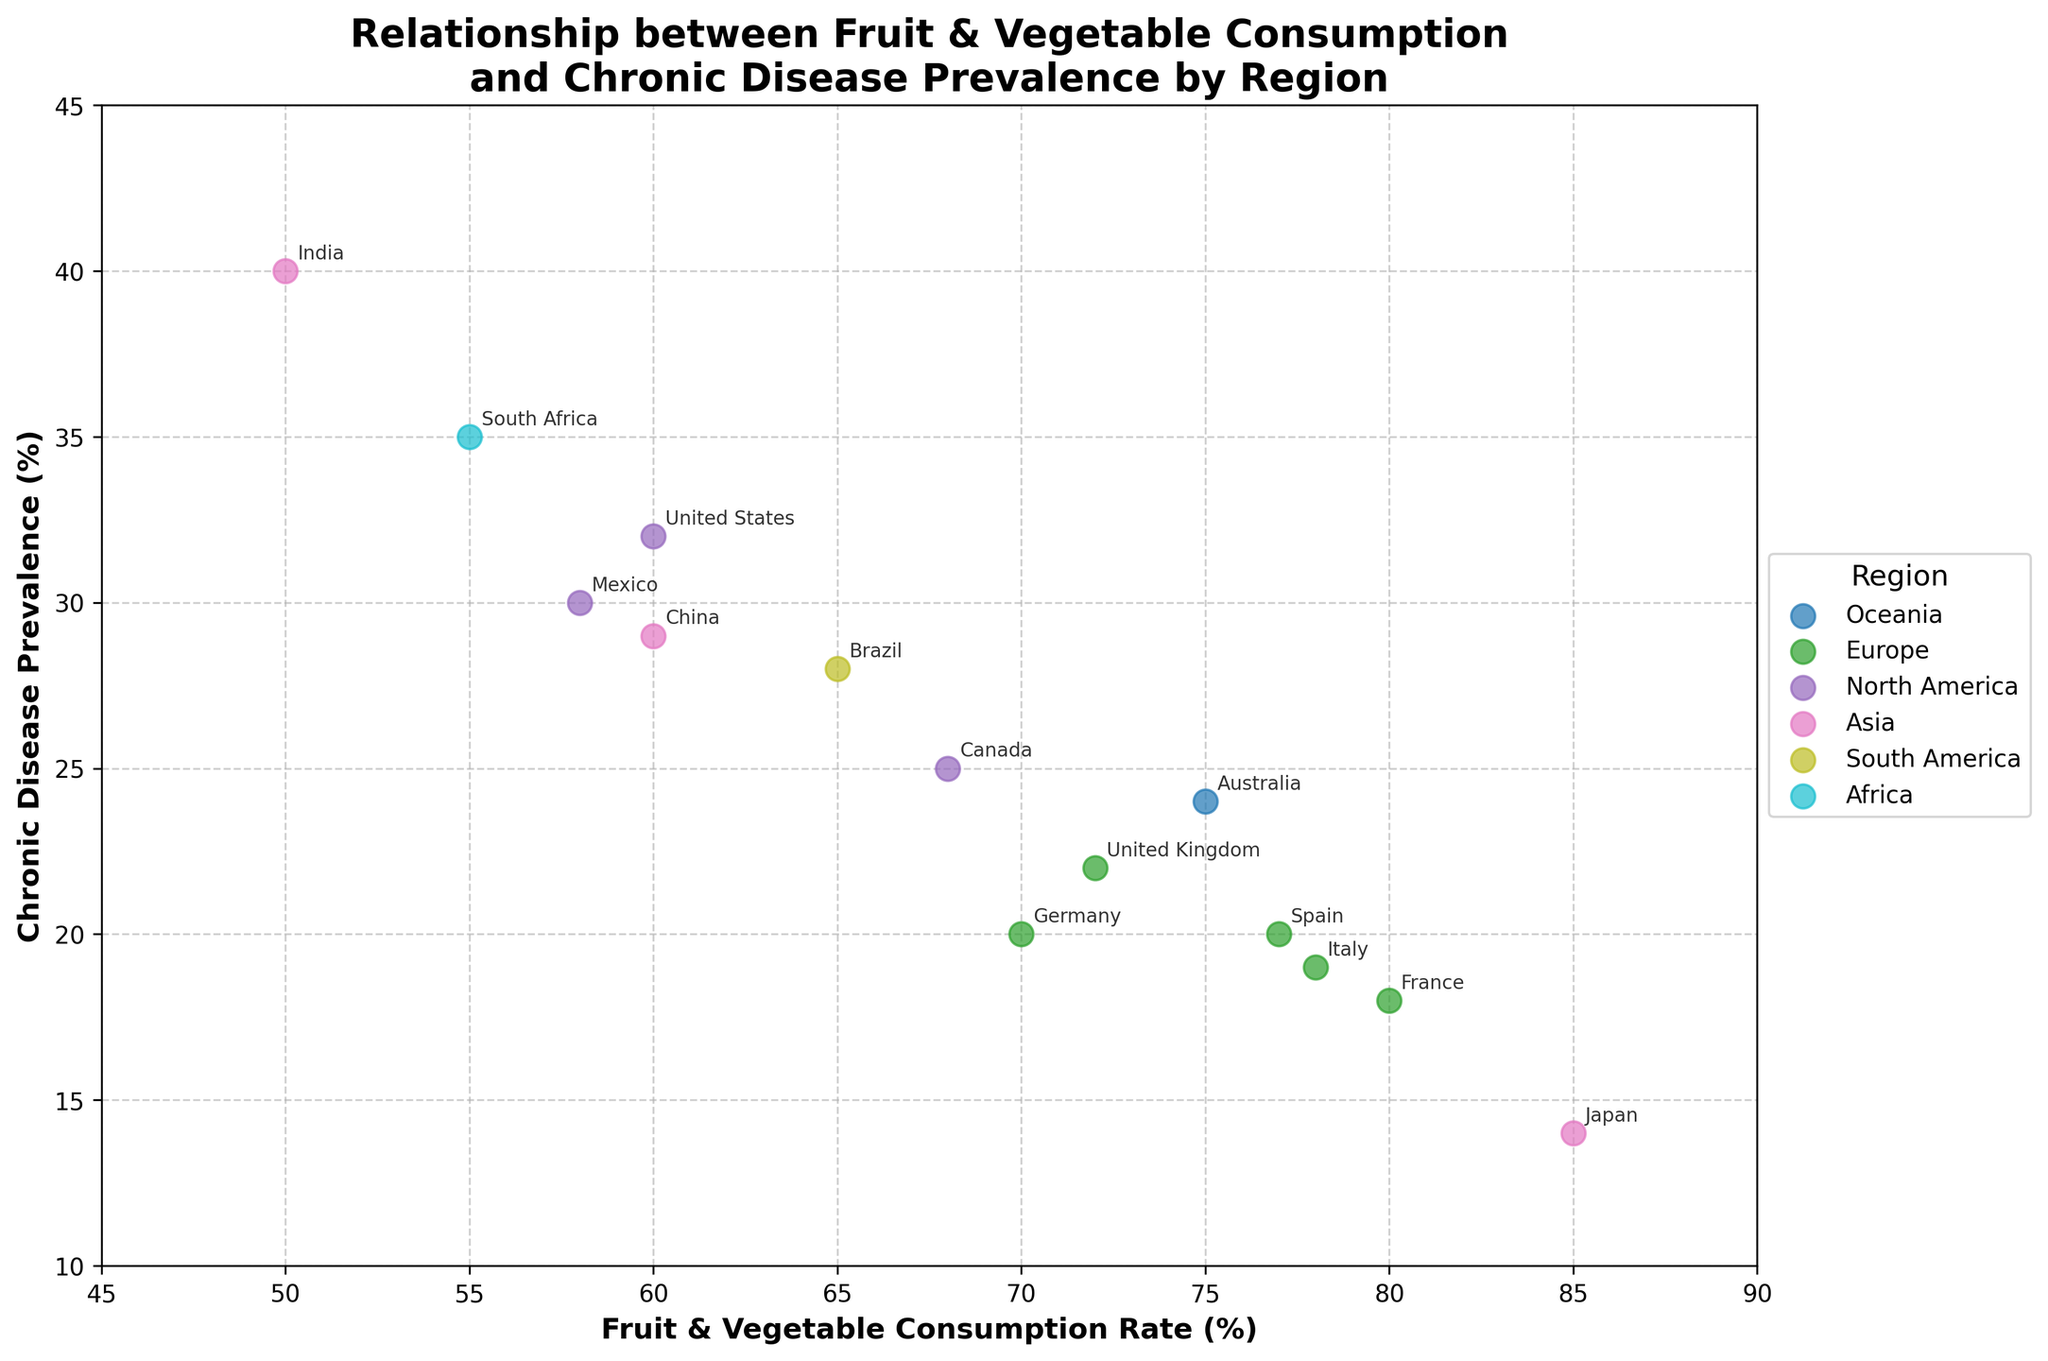What is the title of the figure? The title is prominently displayed at the top of the figure. It reads: "Relationship between Fruit & Vegetable Consumption and Chronic Disease Prevalence by Region".
Answer: Relationship between Fruit & Vegetable Consumption and Chronic Disease Prevalence by Region Which region has the highest fruit and vegetable consumption rate? To find the region with the highest consumption rate, look for the highest point on the x-axis. Japan is at 85%, which is the highest.
Answer: Japan How many countries from Asia are shown in the plot? Identify the points labeled with Asian countries. These are Japan, India, and China, making a total of 3.
Answer: 3 What is the fruit and vegetable consumption rate for France? Find the point labeled "France" and check its position on the x-axis. The consumption rate is 80%.
Answer: 80% Which country has the highest chronic disease prevalence rate and what is it? Look for the highest point on the y-axis. India has the highest chronic disease prevalence at 40%.
Answer: India, 40% Compare the fruit and vegetable consumption rates between the United Kingdom and Canada. Which country has a higher rate? Locate both countries on the plot and compare their positions on the x-axis. The United Kingdom has a rate of 72%, and Canada has 68%. The United Kingdom has a higher rate.
Answer: United Kingdom Is there a noticeable pattern indicating a relationship between fruit and vegetable consumption rates and chronic disease prevalence? Observe the overall trend of the points. There is an inverse relationship; generally, higher consumption rates correspond to lower chronic disease prevalence.
Answer: Inverse relationship Which region has the most countries represented in the plot? Count the number of countries per region. Europe has France, Germany, United Kingdom, Italy, and Spain, totaling 5 countries, which is the most.
Answer: Europe What is the fruit and vegetable consumption rate difference between Australia and Mexico? Find their positions on the x-axis. Australia's rate is 75% and Mexico's is 58%. The difference is 75% - 58% = 17%.
Answer: 17% Which regions have countries with more than 70% fruit and vegetable consumption? Look for points to the right of the 70% mark on the x-axis and check their regions. Oceania (Australia), Europe (France, Italy, Spain, United Kingdom), and Asia (Japan) have countries above 70%.
Answer: Oceania, Europe, Asia 